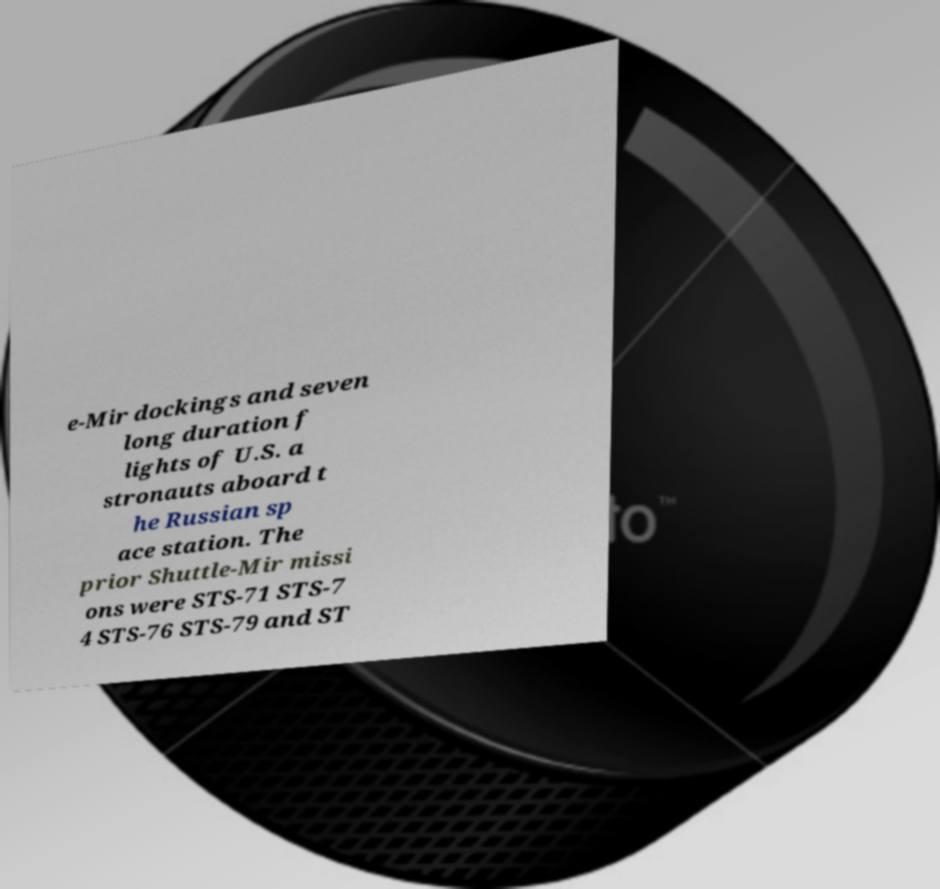There's text embedded in this image that I need extracted. Can you transcribe it verbatim? e-Mir dockings and seven long duration f lights of U.S. a stronauts aboard t he Russian sp ace station. The prior Shuttle-Mir missi ons were STS-71 STS-7 4 STS-76 STS-79 and ST 